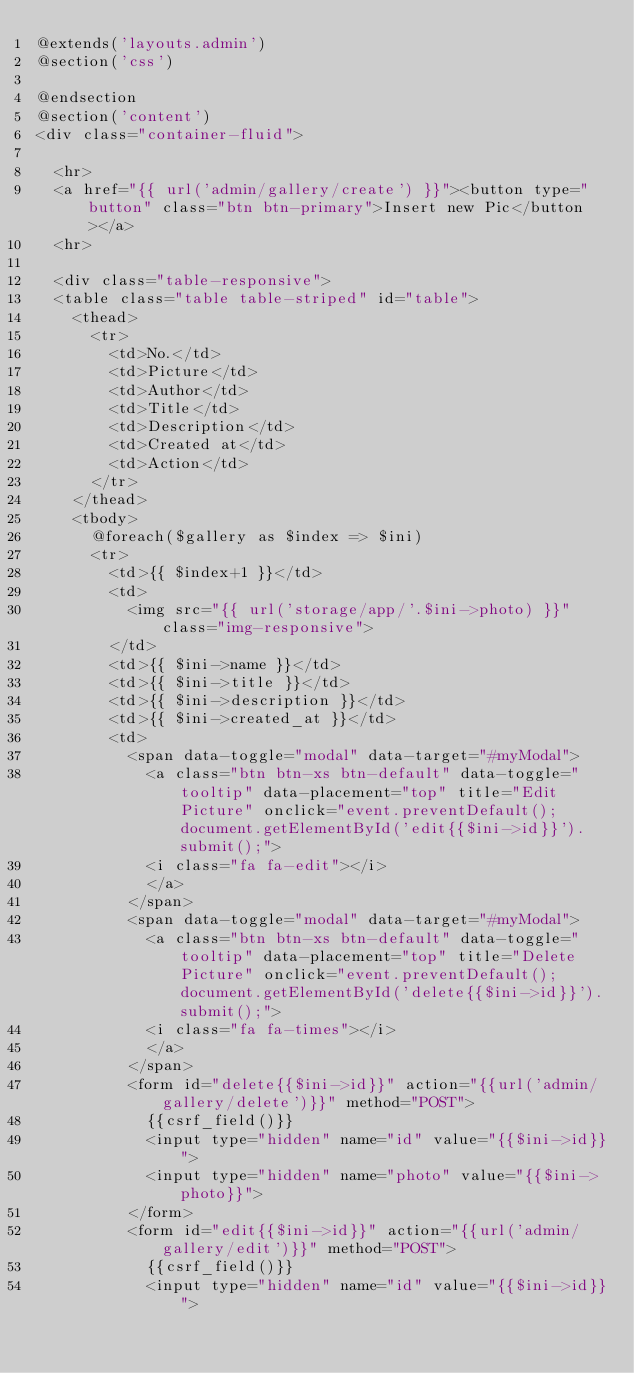Convert code to text. <code><loc_0><loc_0><loc_500><loc_500><_PHP_>@extends('layouts.admin')
@section('css')

@endsection
@section('content')
<div class="container-fluid">
	
	<hr>
	<a href="{{ url('admin/gallery/create') }}"><button type="button" class="btn btn-primary">Insert new Pic</button></a>
	<hr>

	<div class="table-responsive">
	<table class="table table-striped" id="table">
		<thead>
			<tr>
				<td>No.</td>
				<td>Picture</td>
				<td>Author</td>
				<td>Title</td>
				<td>Description</td>
				<td>Created at</td>
				<td>Action</td>
			</tr>	
		</thead>
		<tbody>
			@foreach($gallery as $index => $ini)
			<tr>
				<td>{{ $index+1 }}</td>
				<td>
					<img src="{{ url('storage/app/'.$ini->photo) }}" class="img-responsive">
				</td>
				<td>{{ $ini->name }}</td>
				<td>{{ $ini->title }}</td>
				<td>{{ $ini->description }}</td>
				<td>{{ $ini->created_at }}</td>
				<td>
					<span data-toggle="modal" data-target="#myModal">
						<a class="btn btn-xs btn-default" data-toggle="tooltip" data-placement="top" title="Edit Picture" onclick="event.preventDefault();document.getElementById('edit{{$ini->id}}').submit();">
						<i class="fa fa-edit"></i>
						</a>
					</span>
					<span data-toggle="modal" data-target="#myModal">
						<a class="btn btn-xs btn-default" data-toggle="tooltip" data-placement="top" title="Delete Picture" onclick="event.preventDefault();document.getElementById('delete{{$ini->id}}').submit();">
						<i class="fa fa-times"></i>
						</a>
					</span>
					<form id="delete{{$ini->id}}" action="{{url('admin/gallery/delete')}}" method="POST">
						{{csrf_field()}}
						<input type="hidden" name="id" value="{{$ini->id}}">
						<input type="hidden" name="photo" value="{{$ini->photo}}">
					</form>
					<form id="edit{{$ini->id}}" action="{{url('admin/gallery/edit')}}" method="POST">
						{{csrf_field()}}
						<input type="hidden" name="id" value="{{$ini->id}}"></code> 